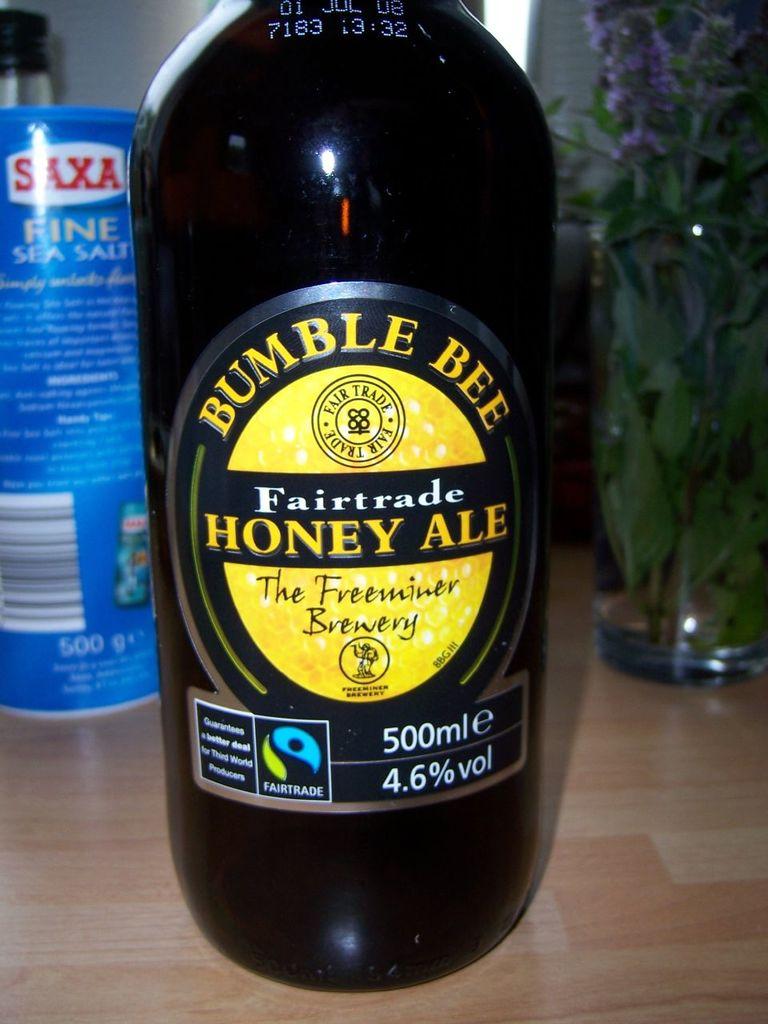What is name of this fairtrade honey ale?
Your answer should be compact. Bumble bee. What is the name of this ale?
Give a very brief answer. Honey ale. 